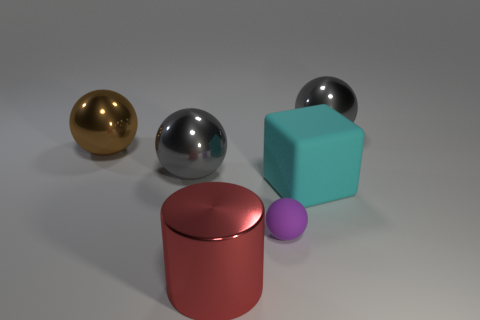Are there any other things that are the same size as the purple matte ball?
Keep it short and to the point. No. The matte object that is the same size as the brown metallic object is what shape?
Your answer should be very brief. Cube. What number of large objects are either red cylinders or cyan rubber cubes?
Provide a short and direct response. 2. The tiny sphere that is the same material as the big cyan thing is what color?
Your answer should be compact. Purple. There is a large metal object that is to the right of the small matte ball; does it have the same shape as the gray metallic object on the left side of the tiny purple thing?
Provide a short and direct response. Yes. What number of matte things are big yellow cylinders or large gray things?
Provide a succinct answer. 0. Is there any other thing that has the same shape as the big brown thing?
Keep it short and to the point. Yes. What is the large red thing in front of the brown metallic ball made of?
Keep it short and to the point. Metal. Do the gray object that is to the left of the small purple object and the small sphere have the same material?
Give a very brief answer. No. How many objects are big objects or big metallic balls that are behind the large brown thing?
Offer a very short reply. 5. 